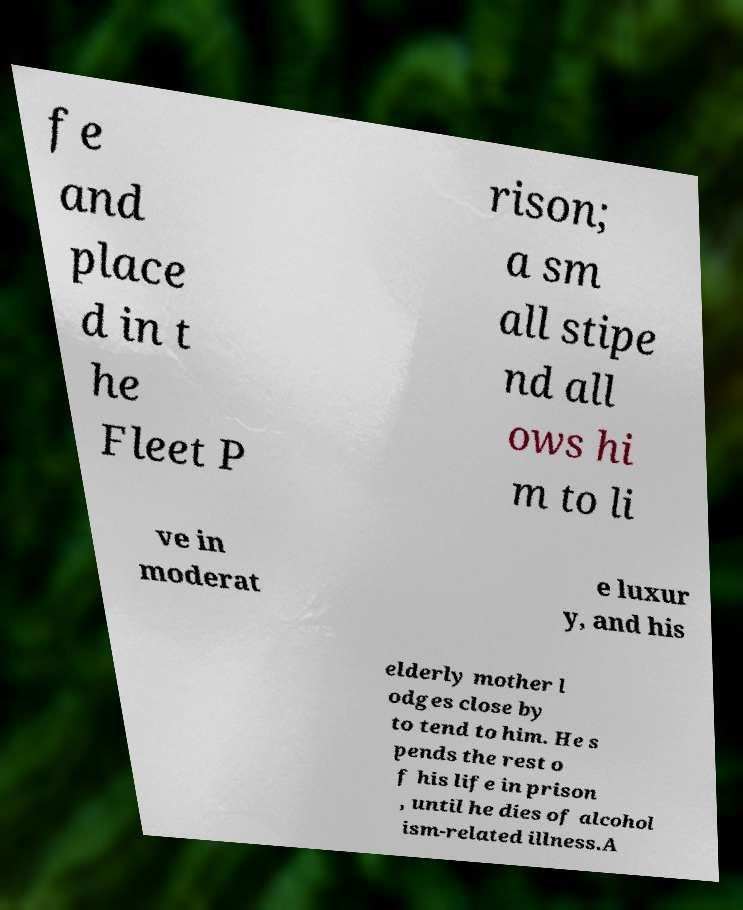Can you accurately transcribe the text from the provided image for me? fe and place d in t he Fleet P rison; a sm all stipe nd all ows hi m to li ve in moderat e luxur y, and his elderly mother l odges close by to tend to him. He s pends the rest o f his life in prison , until he dies of alcohol ism-related illness.A 